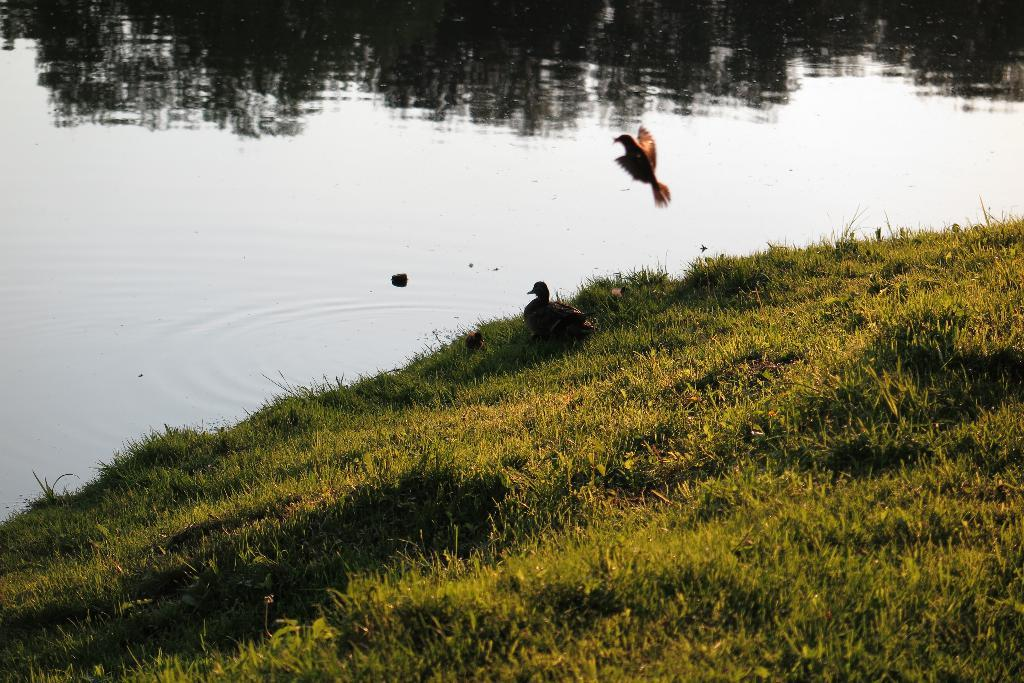How many birds can be seen in the image? There are two birds in the image. What type of vegetation is present in the image? There is grass in the image. What can be seen in the background of the image? There is water visible in the background of the image. What type of crown is the bird wearing in the image? There is no crown present in the image; the birds are not wearing any accessories. 